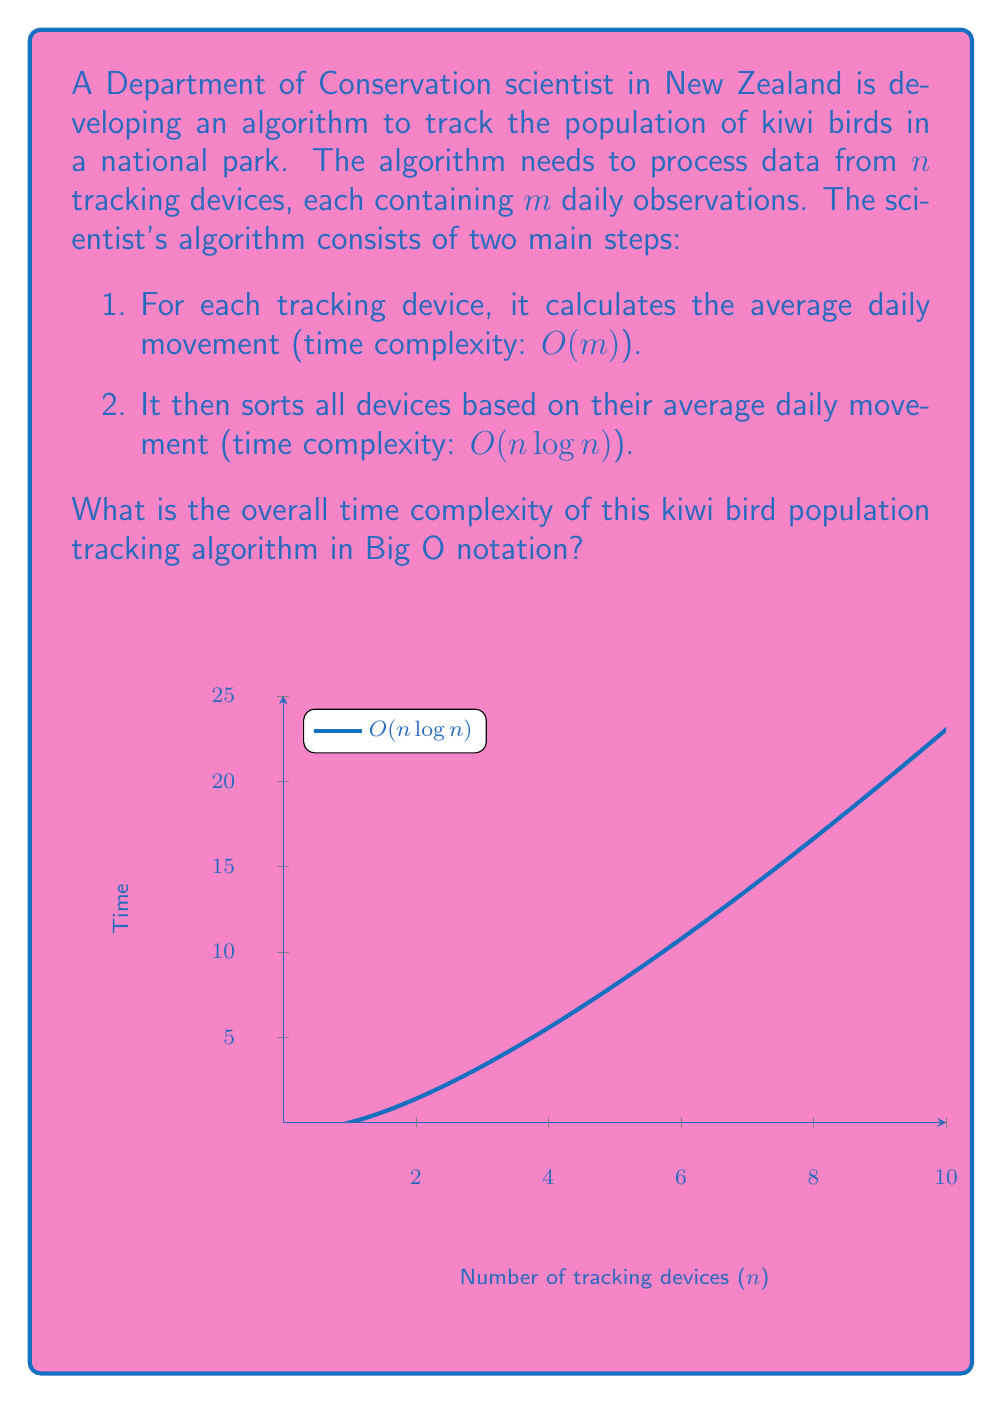Can you solve this math problem? To determine the overall time complexity, we need to analyze each step of the algorithm:

1. Calculating average daily movement:
   - This step is performed for each of the $n$ tracking devices.
   - For each device, it processes $m$ daily observations.
   - The time complexity for one device is $O(m)$.
   - For all $n$ devices, the time complexity is $O(n \cdot m)$.

2. Sorting devices based on average daily movement:
   - This step involves sorting $n$ items.
   - The time complexity of an efficient sorting algorithm (e.g., merge sort or quicksort) is $O(n \log n)$.

To get the overall time complexity, we add these two steps:

$O(n \cdot m) + O(n \log n)$

Now, we need to determine which term dominates as $n$ and $m$ grow large. There are two cases to consider:

Case 1: If $m$ is constant or grows slower than $\log n$:
- $O(n \cdot m)$ becomes $O(n)$
- $O(n \log n)$ dominates

Case 2: If $m$ grows faster than $\log n$:
- $O(n \cdot m)$ dominates

Since we don't have specific information about the growth of $m$ relative to $n$, we express the overall time complexity as:

$O(\max(n \cdot m, n \log n))$

This notation indicates that the time complexity is the larger of the two terms.
Answer: $O(\max(n \cdot m, n \log n))$ 